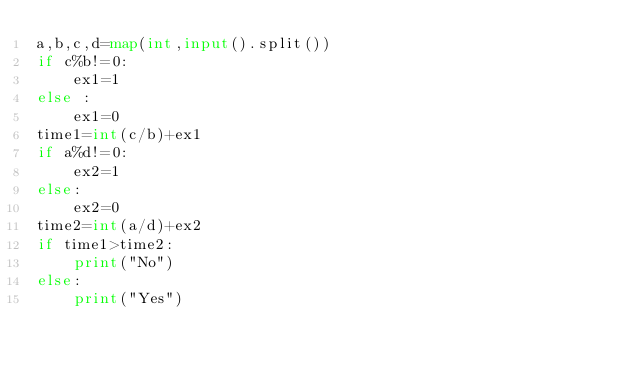<code> <loc_0><loc_0><loc_500><loc_500><_Python_>a,b,c,d=map(int,input().split())
if c%b!=0:
    ex1=1
else :
    ex1=0
time1=int(c/b)+ex1
if a%d!=0:
    ex2=1
else:
    ex2=0
time2=int(a/d)+ex2
if time1>time2:
    print("No")
else:
    print("Yes")</code> 